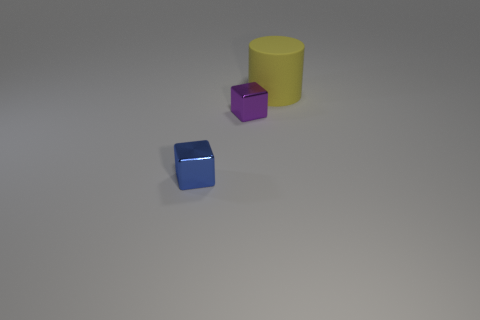The shiny thing that is left of the block behind the tiny block to the left of the tiny purple metal object is what color?
Provide a succinct answer. Blue. Is the number of tiny blue metallic things left of the yellow cylinder the same as the number of large yellow rubber cylinders that are on the left side of the small blue metallic block?
Provide a succinct answer. No. The purple metal object that is the same size as the blue metallic thing is what shape?
Provide a succinct answer. Cube. Is there a matte cylinder of the same color as the large thing?
Give a very brief answer. No. There is a tiny shiny object to the right of the tiny blue metallic block; what is its shape?
Your response must be concise. Cube. What is the color of the large rubber object?
Your response must be concise. Yellow. What color is the small object that is made of the same material as the small purple block?
Your answer should be compact. Blue. How many small objects are the same material as the big yellow thing?
Provide a succinct answer. 0. How many rubber things are in front of the tiny purple cube?
Offer a very short reply. 0. Is the block right of the blue object made of the same material as the tiny thing in front of the small purple metal object?
Your answer should be compact. Yes. 